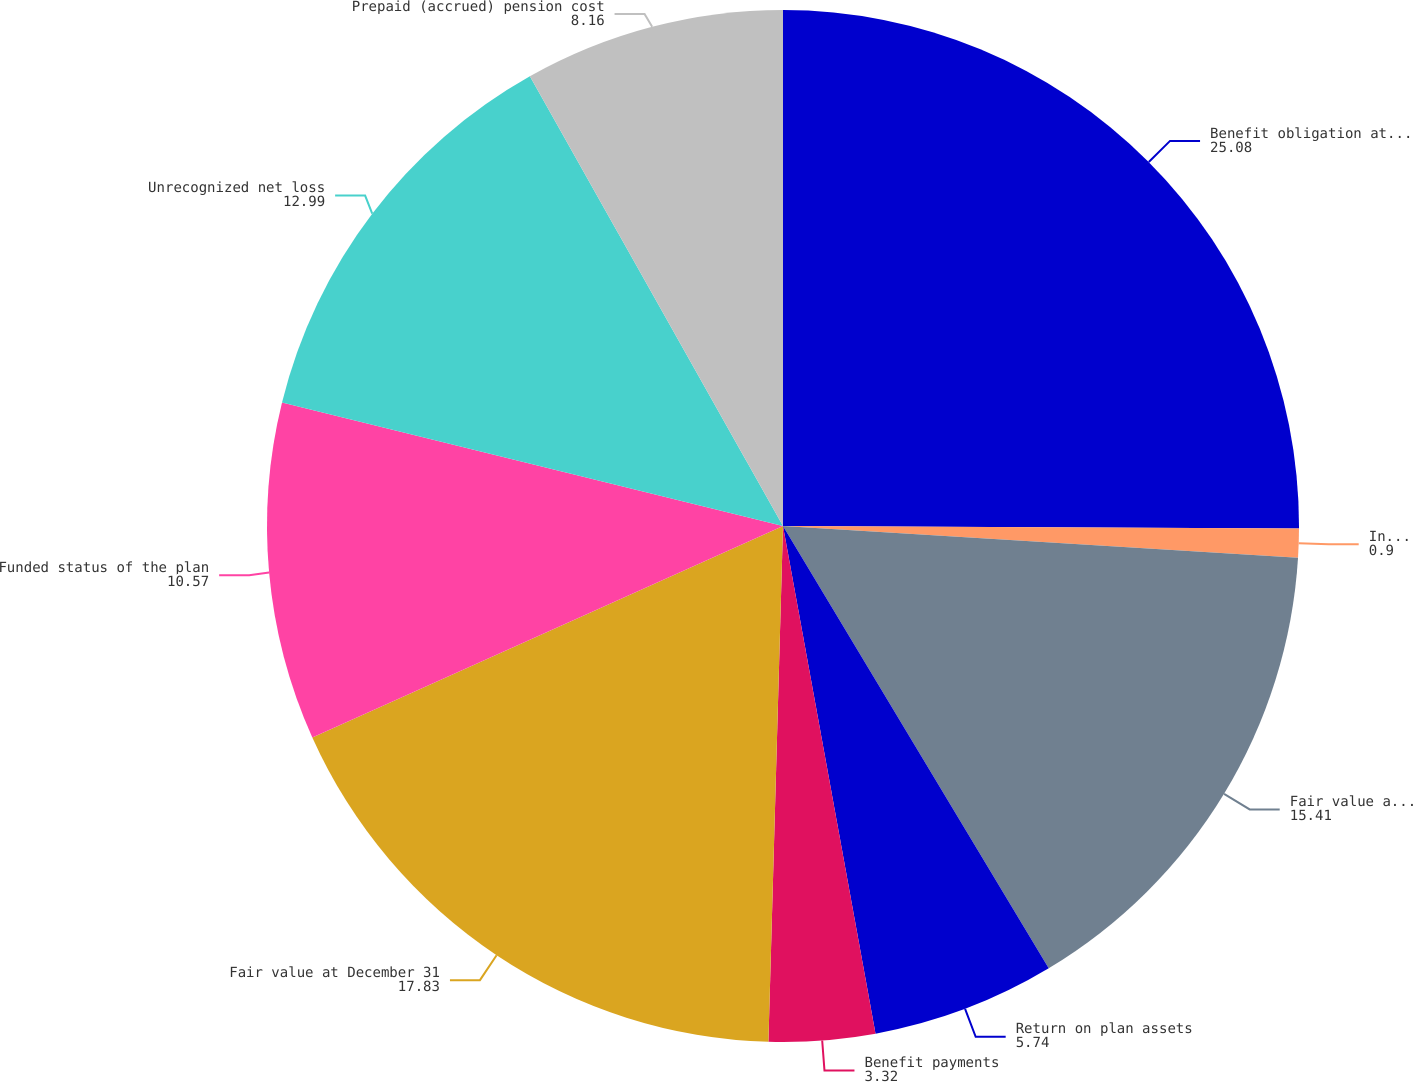Convert chart. <chart><loc_0><loc_0><loc_500><loc_500><pie_chart><fcel>Benefit obligation at January<fcel>Interest cost Plan amendments<fcel>Fair value at January 1<fcel>Return on plan assets<fcel>Benefit payments<fcel>Fair value at December 31<fcel>Funded status of the plan<fcel>Unrecognized net loss<fcel>Prepaid (accrued) pension cost<nl><fcel>25.08%<fcel>0.9%<fcel>15.41%<fcel>5.74%<fcel>3.32%<fcel>17.83%<fcel>10.57%<fcel>12.99%<fcel>8.16%<nl></chart> 